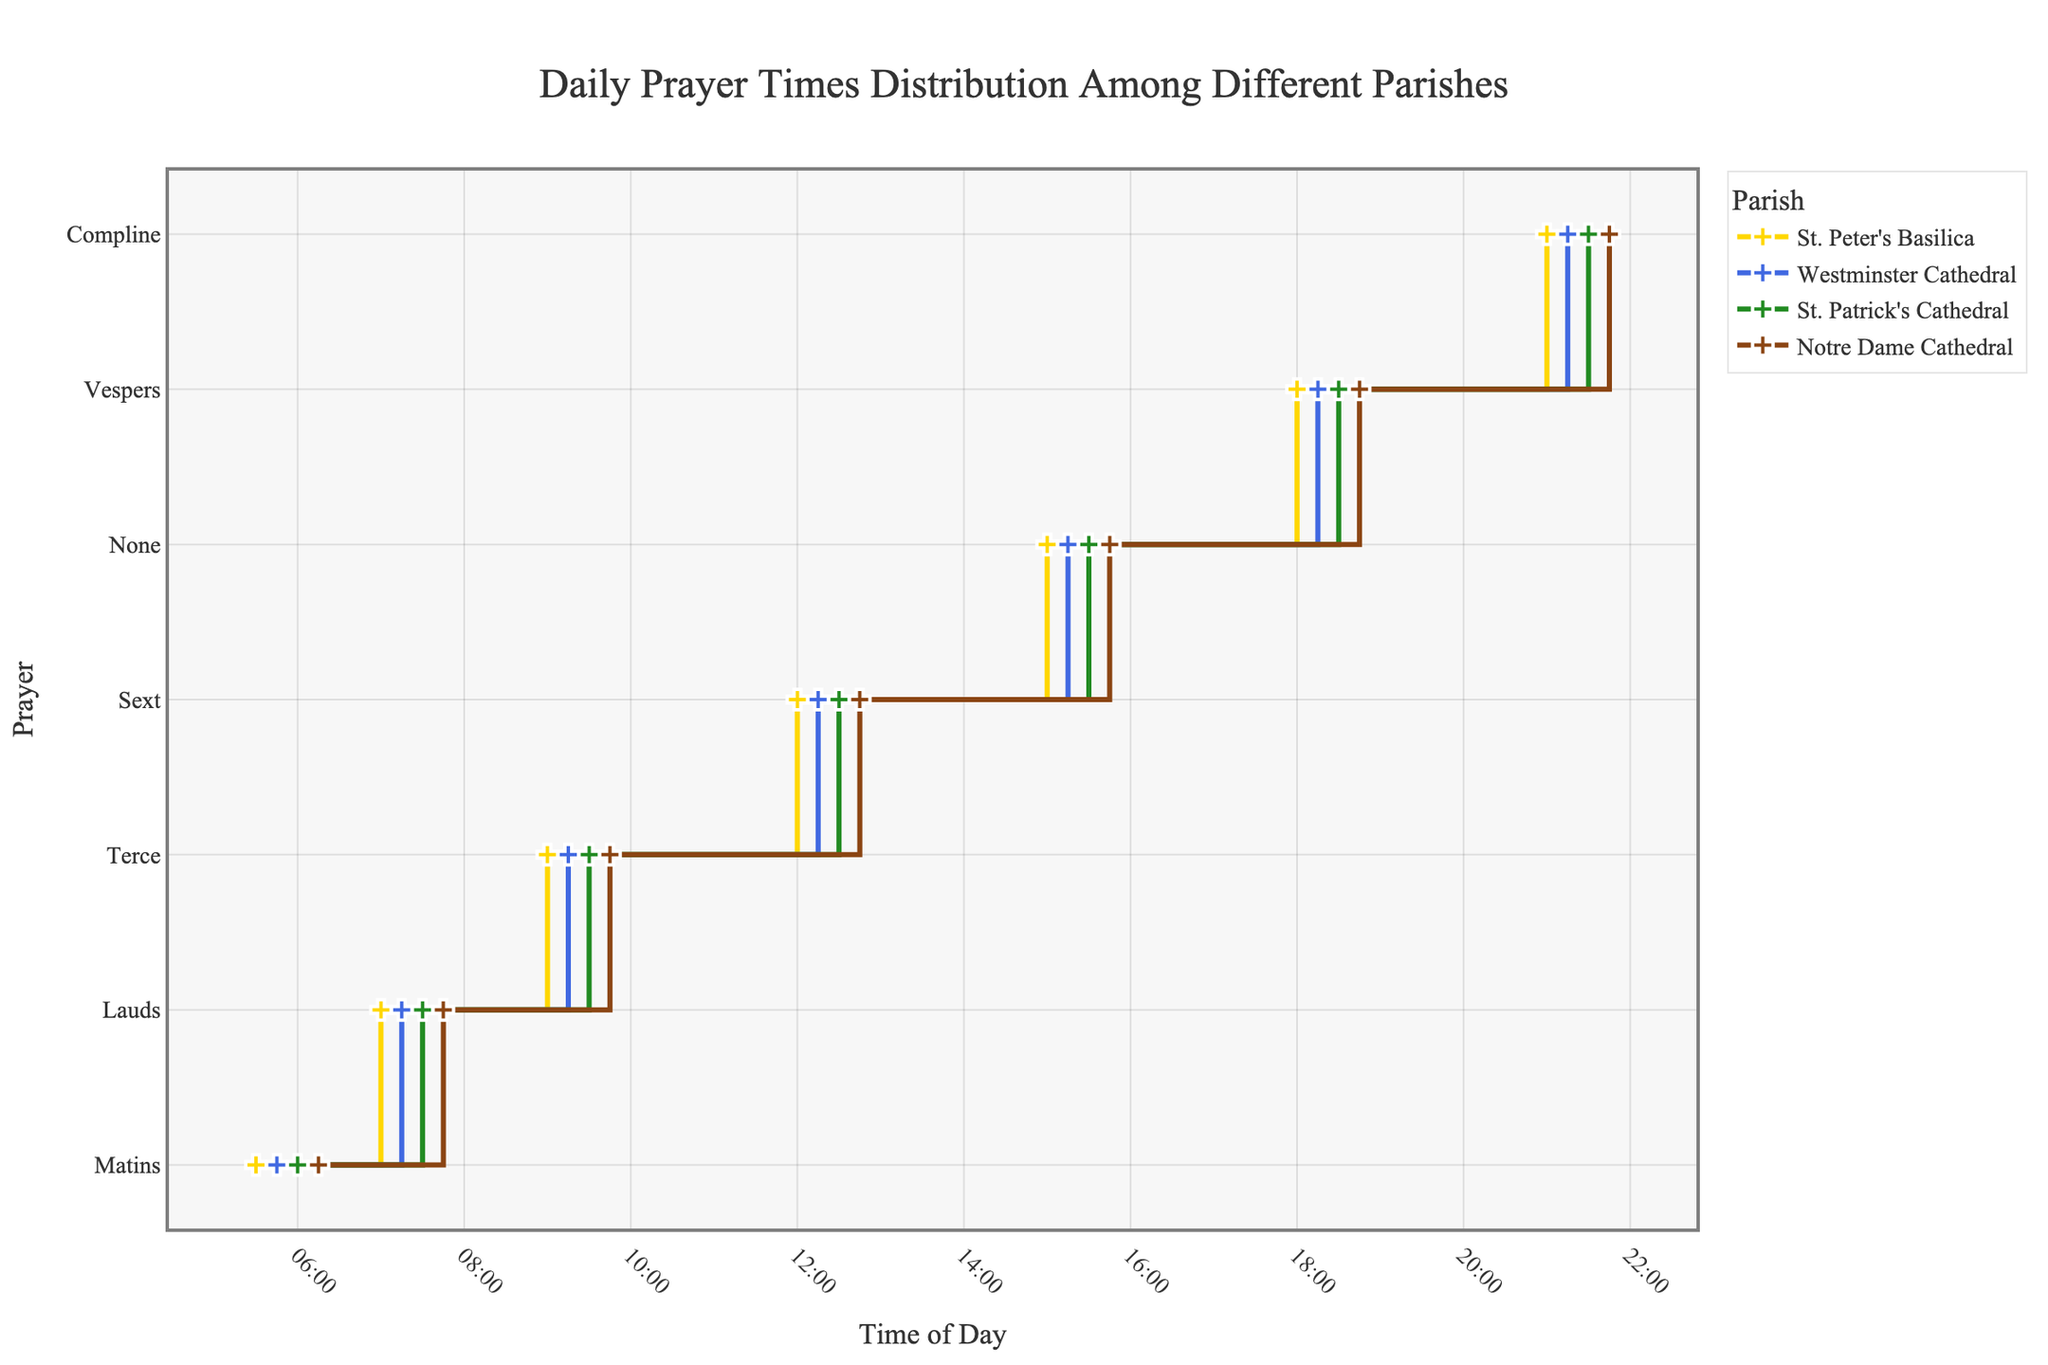What is the title of the figure? The title is located at the top center of the figure and usually describes the overall theme or subject. The title font is also larger than other text.
Answer: Daily Prayer Times Distribution Among Different Parishes How many parishes are included in this figure? You can count the unique lines (or colors) and refer to the legend that specifies the different parishes. Each line represents a different parish.
Answer: 4 Which prayer occurs earliest at St. Patrick's Cathedral? By observing the prayer times for each parish, you can see that Matins at St. Patrick's Cathedral is the first prayer of the day. The order is based on the time-axis from left to right.
Answer: Matins What time does Compline start at Notre Dame Cathedral? Locate the Notre Dame Cathedral line (color-coded) and trace it to the Compline label on the y-axis, then read the corresponding time on the x-axis.
Answer: 21:45 What is the time difference between Matins at St. Peter's Basilica and Matins at Westminster Cathedral? Find the times for Matins at both St. Peter's Basilica and Westminster Cathedral. Calculate the difference by subtracting the earlier time from the later time.
Answer: 15 minutes Which parish has the latest morning prayer (Matins)? Compare the times of Matins across all parishes on the stair plot. The latest time is the one furthest to the right on the x-axis.
Answer: Notre Dame Cathedral At what times do Vespers occur across the four parishes? Vespers times can be identified for each parish by finding the label Vespers on the y-axis and checking each corresponding x-axis time for all lines representing each parish.
Answer: 18:00, 18:15, 18:30, 18:45 Which prayer time is exactly at noon (12:00) for any parish? Locate the time 12:00 on the x-axis and check which prayer coincides with that time for any of the parishes by following the trace lines vertically.
Answer: Sext at St. Peter's Basilica How does the Matins time at St. Peter's Basilica compare with the Matins time at Notre Dame Cathedral? Compare both Matins times visible in the respective parish lines (color-coded) and x-axis positions for St. Peter's Basilica and Notre Dame Cathedral. Note the relationship (earlier or later).
Answer: St. Peter's Basilica is earlier Is there any parish where Compline is later than 21:30? Examine the times for Compline on the x-axis and identify if any Compline time for the parishes exceeds 21:30.
Answer: Yes, Notre Dame Cathedral at 21:45 